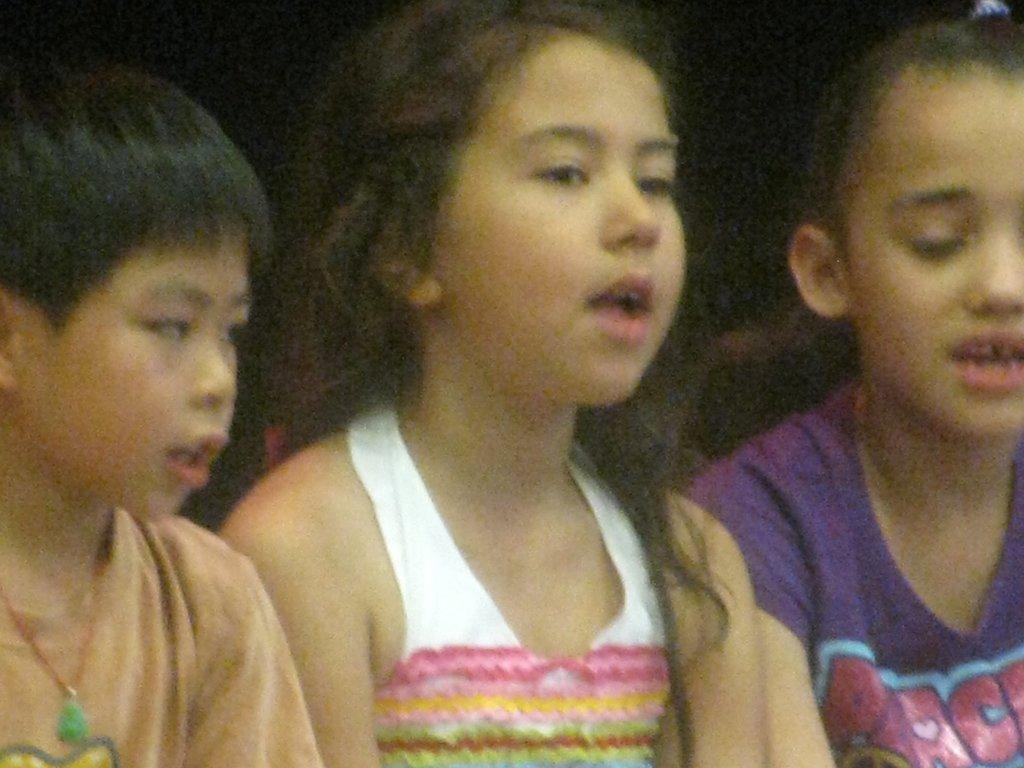How would you summarize this image in a sentence or two? In this image I can see three persons, the person at right is wearing purple color shirt. In front the person is wearing multi color shirt and the person at left is wearing brown color shirt and I can see the dark background. 